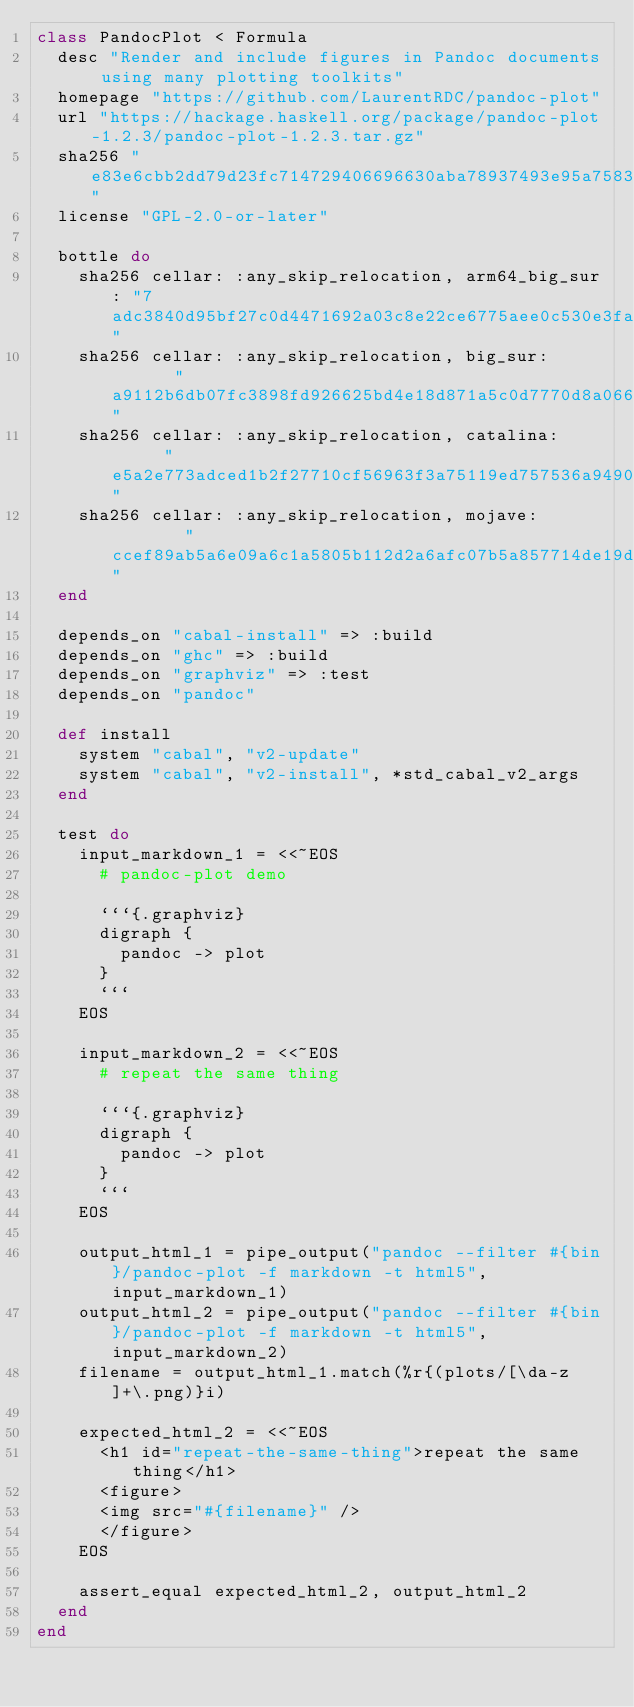Convert code to text. <code><loc_0><loc_0><loc_500><loc_500><_Ruby_>class PandocPlot < Formula
  desc "Render and include figures in Pandoc documents using many plotting toolkits"
  homepage "https://github.com/LaurentRDC/pandoc-plot"
  url "https://hackage.haskell.org/package/pandoc-plot-1.2.3/pandoc-plot-1.2.3.tar.gz"
  sha256 "e83e6cbb2dd79d23fc714729406696630aba78937493e95a758389395ff5fd64"
  license "GPL-2.0-or-later"

  bottle do
    sha256 cellar: :any_skip_relocation, arm64_big_sur: "7adc3840d95bf27c0d4471692a03c8e22ce6775aee0c530e3fa843934c50d79c"
    sha256 cellar: :any_skip_relocation, big_sur:       "a9112b6db07fc3898fd926625bd4e18d871a5c0d7770d8a06640a91e1cb77f48"
    sha256 cellar: :any_skip_relocation, catalina:      "e5a2e773adced1b2f27710cf56963f3a75119ed757536a9490fecbb50c377880"
    sha256 cellar: :any_skip_relocation, mojave:        "ccef89ab5a6e09a6c1a5805b112d2a6afc07b5a857714de19d11a308e65c9383"
  end

  depends_on "cabal-install" => :build
  depends_on "ghc" => :build
  depends_on "graphviz" => :test
  depends_on "pandoc"

  def install
    system "cabal", "v2-update"
    system "cabal", "v2-install", *std_cabal_v2_args
  end

  test do
    input_markdown_1 = <<~EOS
      # pandoc-plot demo

      ```{.graphviz}
      digraph {
        pandoc -> plot
      }
      ```
    EOS

    input_markdown_2 = <<~EOS
      # repeat the same thing

      ```{.graphviz}
      digraph {
        pandoc -> plot
      }
      ```
    EOS

    output_html_1 = pipe_output("pandoc --filter #{bin}/pandoc-plot -f markdown -t html5", input_markdown_1)
    output_html_2 = pipe_output("pandoc --filter #{bin}/pandoc-plot -f markdown -t html5", input_markdown_2)
    filename = output_html_1.match(%r{(plots/[\da-z]+\.png)}i)

    expected_html_2 = <<~EOS
      <h1 id="repeat-the-same-thing">repeat the same thing</h1>
      <figure>
      <img src="#{filename}" />
      </figure>
    EOS

    assert_equal expected_html_2, output_html_2
  end
end
</code> 